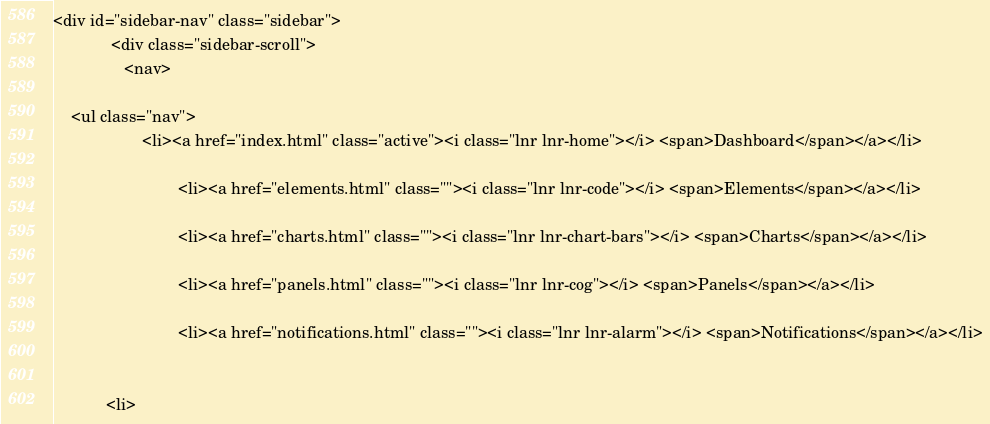<code> <loc_0><loc_0><loc_500><loc_500><_PHP_><div id="sidebar-nav" class="sidebar">
			 <div class="sidebar-scroll">
				<nav>
					
	<ul class="nav">
					<li><a href="index.html" class="active"><i class="lnr lnr-home"></i> <span>Dashboard</span></a></li>

							<li><a href="elements.html" class=""><i class="lnr lnr-code"></i> <span>Elements</span></a></li>

							<li><a href="charts.html" class=""><i class="lnr lnr-chart-bars"></i> <span>Charts</span></a></li>

							<li><a href="panels.html" class=""><i class="lnr lnr-cog"></i> <span>Panels</span></a></li>

							<li><a href="notifications.html" class=""><i class="lnr lnr-alarm"></i> <span>Notifications</span></a></li>

						
			<li></code> 